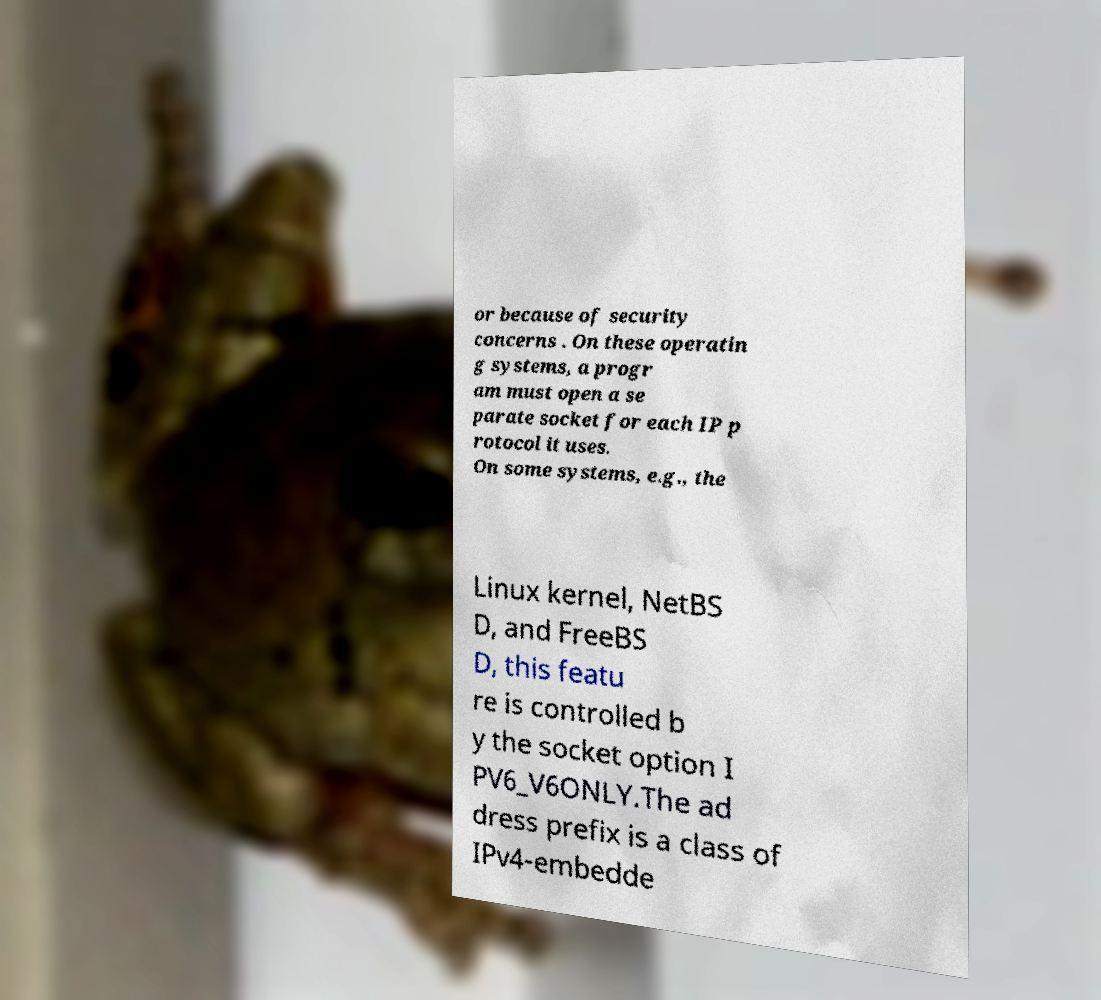I need the written content from this picture converted into text. Can you do that? or because of security concerns . On these operatin g systems, a progr am must open a se parate socket for each IP p rotocol it uses. On some systems, e.g., the Linux kernel, NetBS D, and FreeBS D, this featu re is controlled b y the socket option I PV6_V6ONLY.The ad dress prefix is a class of IPv4-embedde 